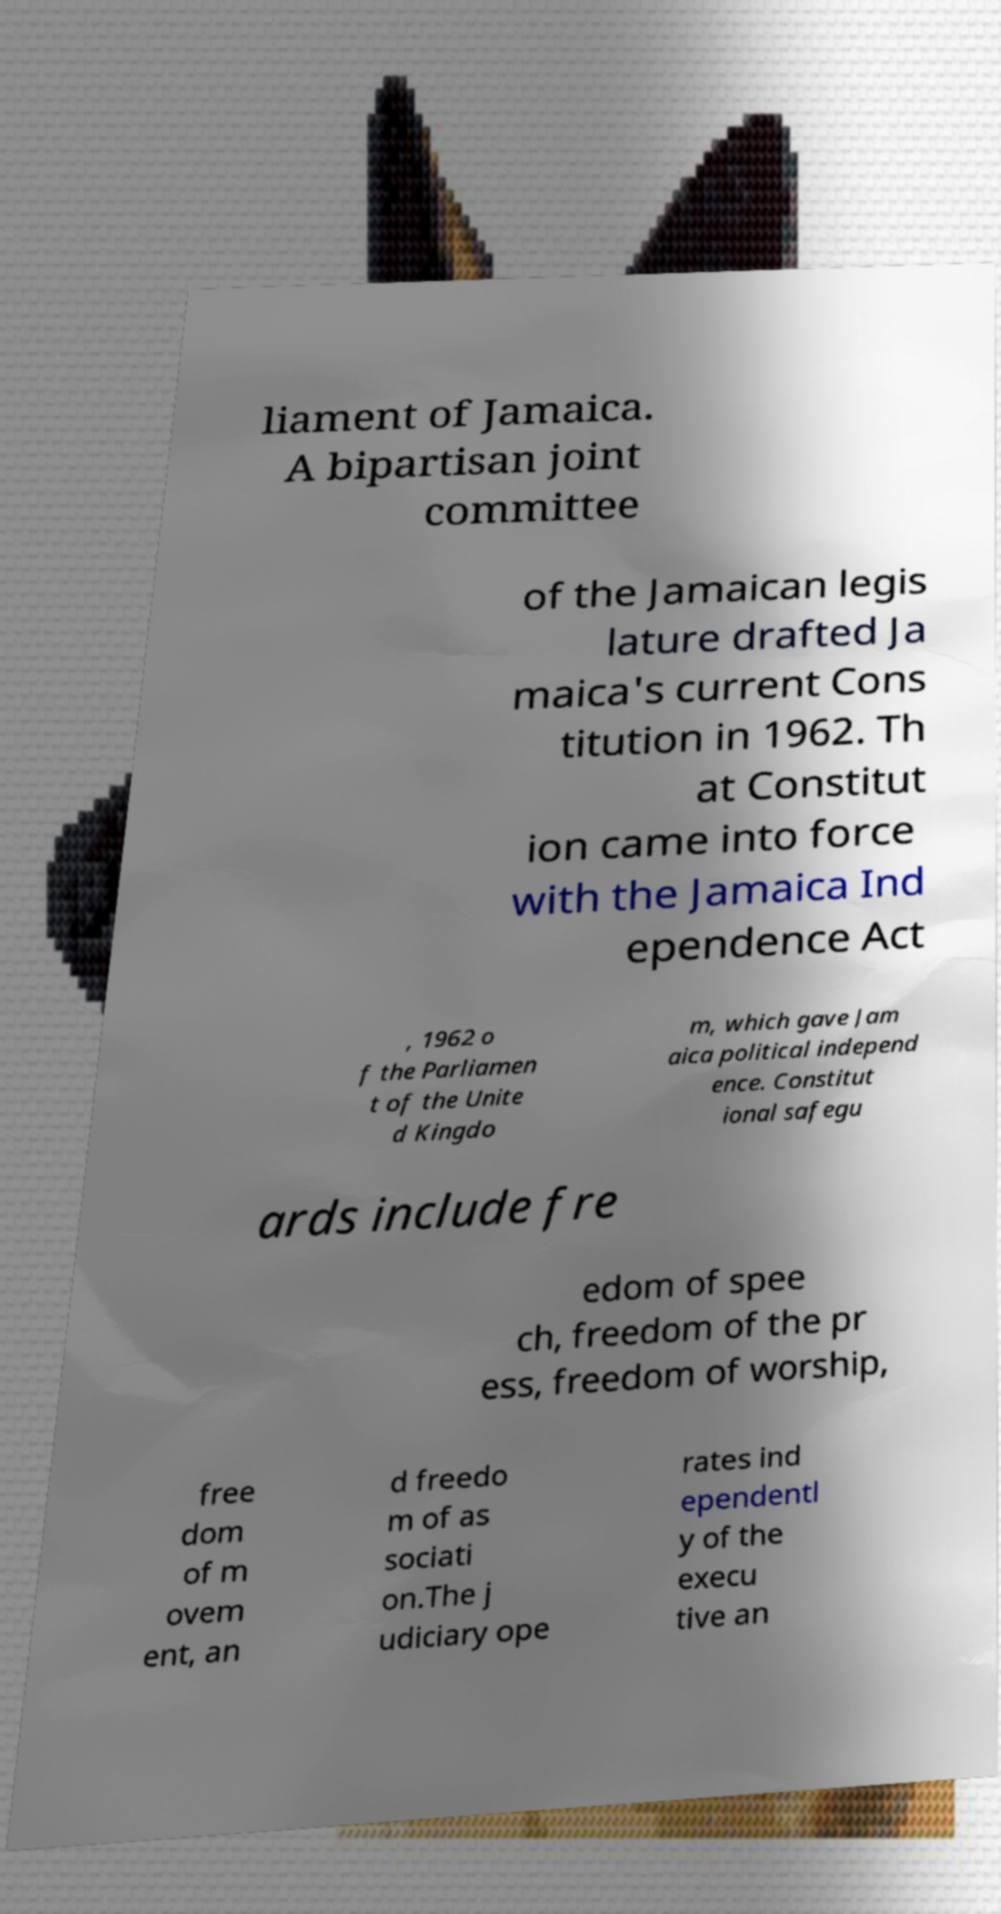Could you extract and type out the text from this image? liament of Jamaica. A bipartisan joint committee of the Jamaican legis lature drafted Ja maica's current Cons titution in 1962. Th at Constitut ion came into force with the Jamaica Ind ependence Act , 1962 o f the Parliamen t of the Unite d Kingdo m, which gave Jam aica political independ ence. Constitut ional safegu ards include fre edom of spee ch, freedom of the pr ess, freedom of worship, free dom of m ovem ent, an d freedo m of as sociati on.The j udiciary ope rates ind ependentl y of the execu tive an 